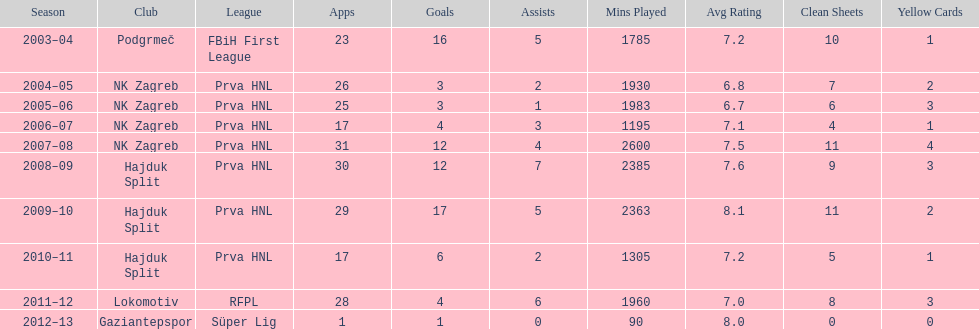At most 26 apps, how many goals were scored in 2004-2005 3. 